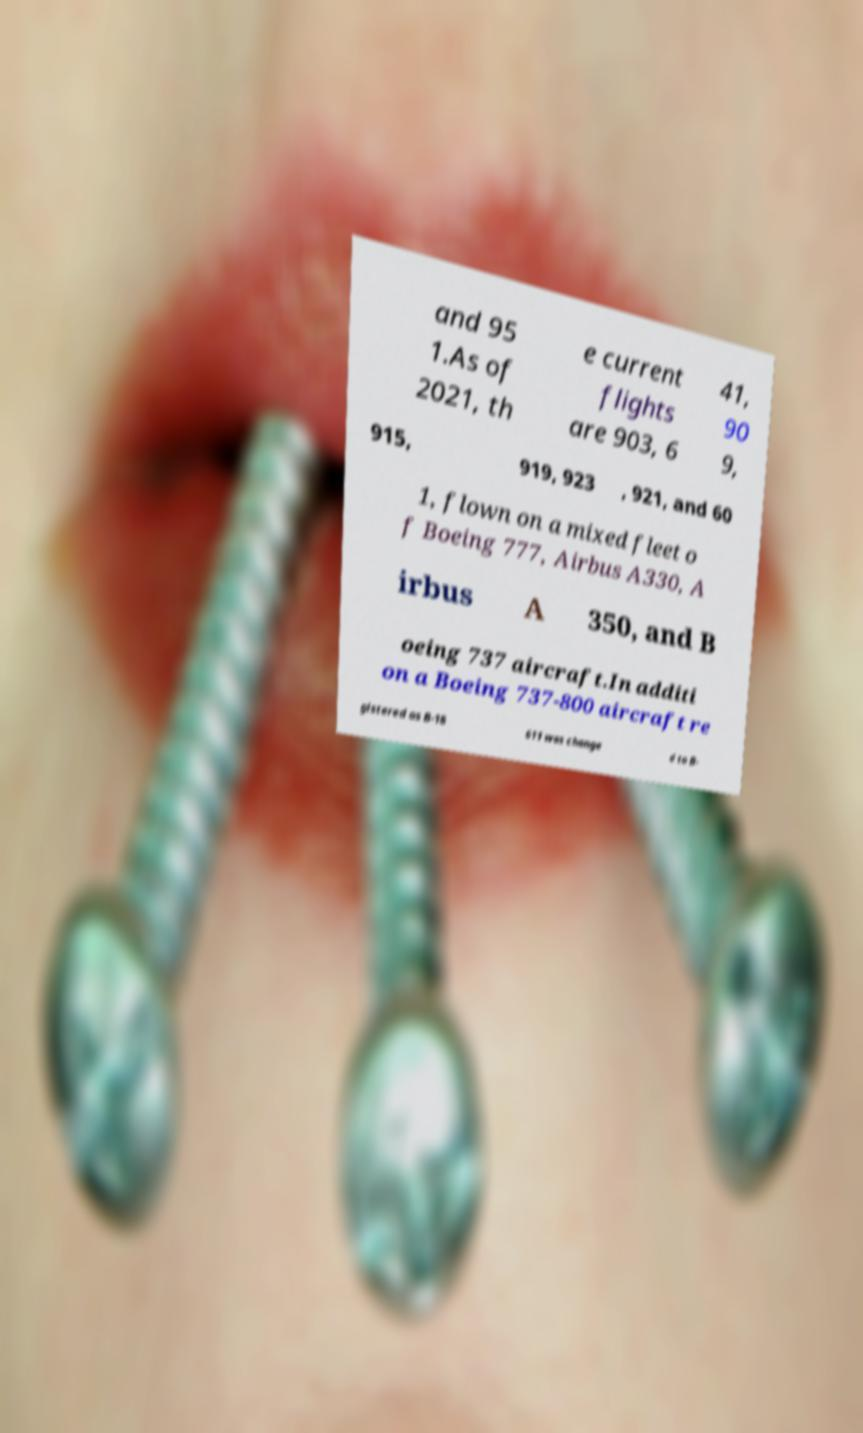Please identify and transcribe the text found in this image. and 95 1.As of 2021, th e current flights are 903, 6 41, 90 9, 915, 919, 923 , 921, and 60 1, flown on a mixed fleet o f Boeing 777, Airbus A330, A irbus A 350, and B oeing 737 aircraft.In additi on a Boeing 737-800 aircraft re gistered as B-18 611 was change d to B- 